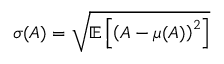Convert formula to latex. <formula><loc_0><loc_0><loc_500><loc_500>\sigma ( A ) = \sqrt { \mathbb { E } \left [ \left ( A - \mu ( A ) \right ) ^ { 2 } \right ] }</formula> 